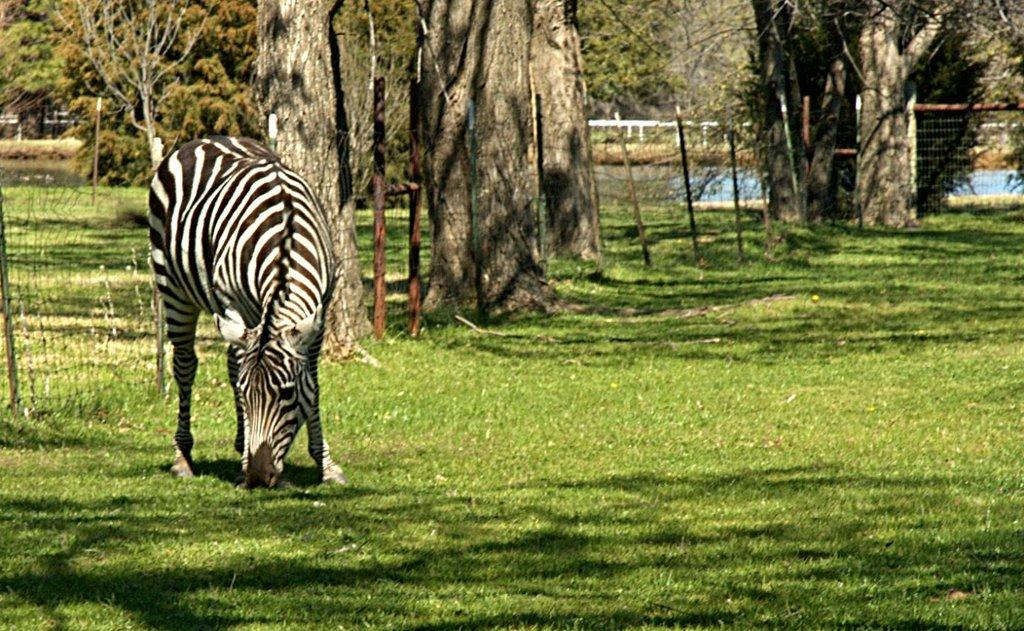What animal can be seen in the picture? There is a zebra in the picture. What is the zebra's position in the picture? The zebra is standing on the ground. What can be seen in the background of the picture? There is a fence, trees, grass, water, and other objects visible in the background of the picture. What type of insurance does the zebra have in the picture? There is no information about insurance in the picture, as it features a zebra standing on the ground with a background of various objects. 